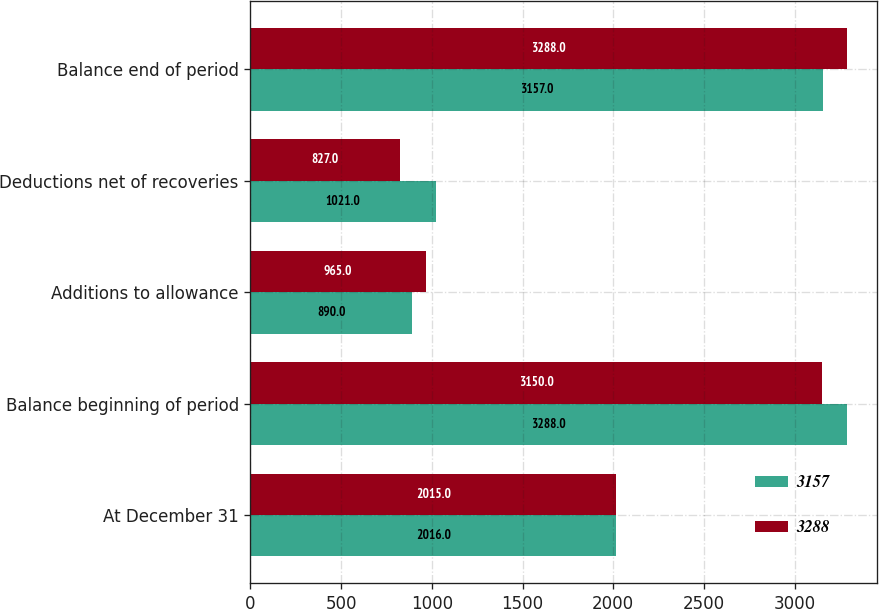Convert chart to OTSL. <chart><loc_0><loc_0><loc_500><loc_500><stacked_bar_chart><ecel><fcel>At December 31<fcel>Balance beginning of period<fcel>Additions to allowance<fcel>Deductions net of recoveries<fcel>Balance end of period<nl><fcel>3157<fcel>2016<fcel>3288<fcel>890<fcel>1021<fcel>3157<nl><fcel>3288<fcel>2015<fcel>3150<fcel>965<fcel>827<fcel>3288<nl></chart> 